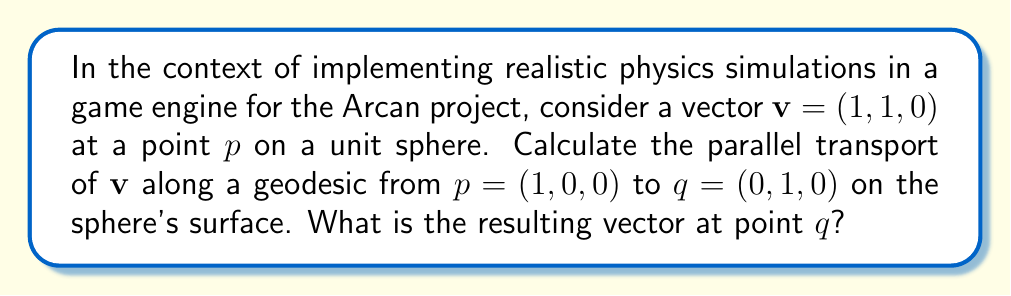Teach me how to tackle this problem. To solve this problem, we'll follow these steps:

1) First, we need to understand that on a sphere, geodesics are great circles. The path from $(1, 0, 0)$ to $(0, 1, 0)$ is a quarter circle in the xy-plane.

2) For parallel transport on a sphere, we use the formula:

   $$\mathbf{v}_\parallel = \mathbf{v} - (\mathbf{v} \cdot \mathbf{n})\mathbf{n}$$

   where $\mathbf{n}$ is the normal vector to the sphere's surface.

3) At the starting point $p = (1, 0, 0)$, the normal vector is the same as the position vector:

   $$\mathbf{n}_p = (1, 0, 0)$$

4) Calculate $\mathbf{v}_\parallel$ at $p$:

   $$\begin{align}
   \mathbf{v}_\parallel &= (1, 1, 0) - ((1, 1, 0) \cdot (1, 0, 0))(1, 0, 0) \\
   &= (1, 1, 0) - (1)(1, 0, 0) \\
   &= (0, 1, 0)
   \end{align}$$

5) Now, we need to rotate this vector by 90° around the z-axis to get to point $q$. The rotation matrix for this is:

   $$R = \begin{pmatrix}
   0 & -1 & 0 \\
   1 & 0 & 0 \\
   0 & 0 & 1
   \end{pmatrix}$$

6) Apply the rotation:

   $$\begin{align}
   \mathbf{v}_q &= R\mathbf{v}_\parallel \\
   &= \begin{pmatrix}
   0 & -1 & 0 \\
   1 & 0 & 0 \\
   0 & 0 & 1
   \end{pmatrix} \begin{pmatrix}
   0 \\
   1 \\
   0
   \end{pmatrix} \\
   &= \begin{pmatrix}
   -1 \\
   0 \\
   0
   \end{pmatrix}
   \end{align}$$

Therefore, the parallel transported vector at point $q$ is $(-1, 0, 0)$.
Answer: $(-1, 0, 0)$ 